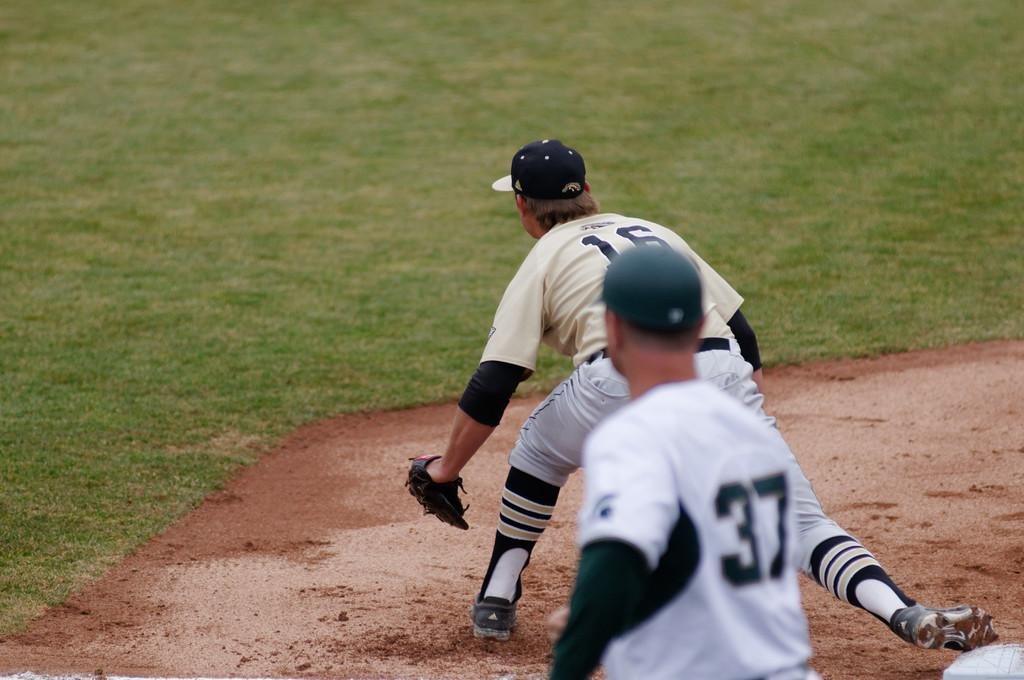Provide a one-sentence caption for the provided image. a player with the number 16 stretching out. 